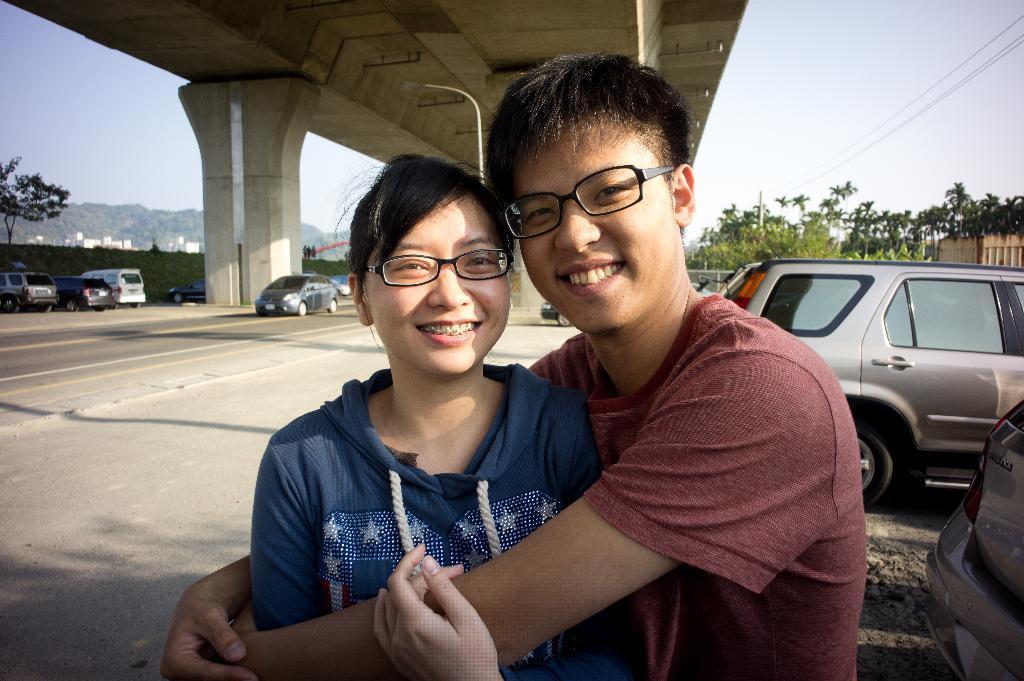Please provide a concise description of this image. In this picture there is a woman who is wearing spectacle and blue hoodie, beside her there is a man who is wearing spectacle and t-shirt. Both of them are smiling. Beside them there are two cars. On the left I can see some cars were parked near to the wall and some cars are running on the road. At the top there is a bridge. In the background I can see the buildings, mountains and poles. In the top left corner there is a sky. In the top right corner I can see the electric wires. 